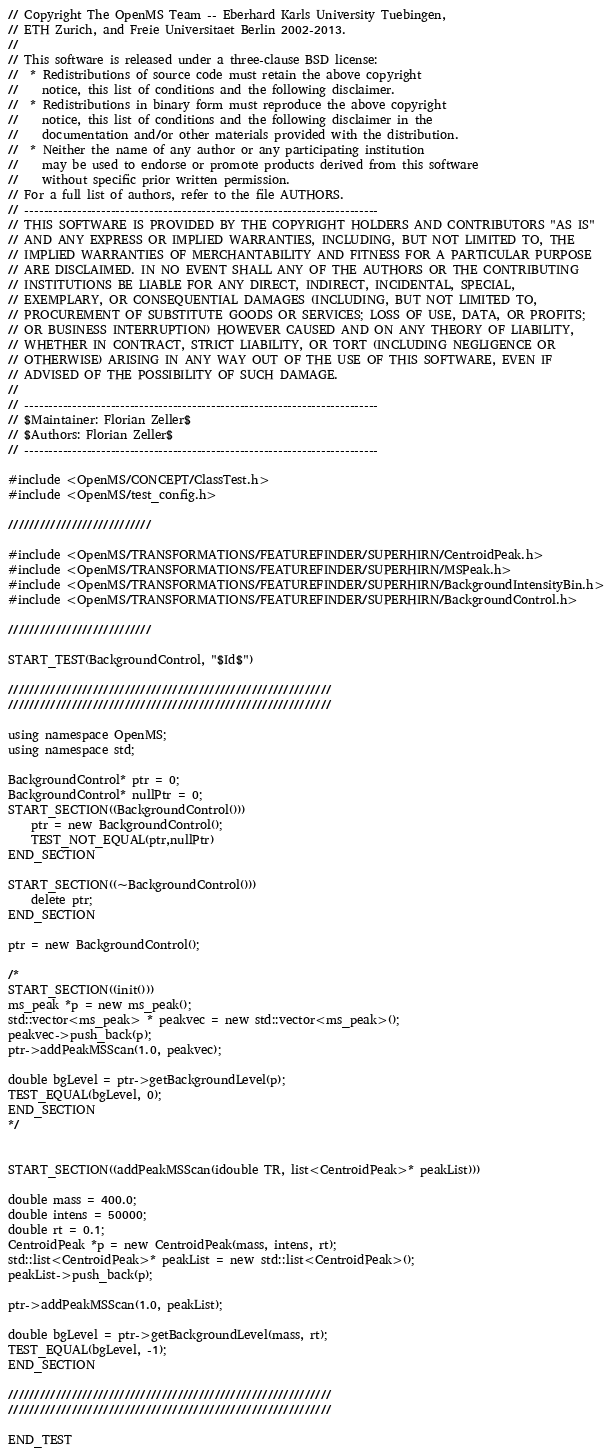Convert code to text. <code><loc_0><loc_0><loc_500><loc_500><_C++_>// Copyright The OpenMS Team -- Eberhard Karls University Tuebingen,
// ETH Zurich, and Freie Universitaet Berlin 2002-2013.
// 
// This software is released under a three-clause BSD license:
//  * Redistributions of source code must retain the above copyright
//    notice, this list of conditions and the following disclaimer.
//  * Redistributions in binary form must reproduce the above copyright
//    notice, this list of conditions and the following disclaimer in the
//    documentation and/or other materials provided with the distribution.
//  * Neither the name of any author or any participating institution 
//    may be used to endorse or promote products derived from this software 
//    without specific prior written permission.
// For a full list of authors, refer to the file AUTHORS. 
// --------------------------------------------------------------------------
// THIS SOFTWARE IS PROVIDED BY THE COPYRIGHT HOLDERS AND CONTRIBUTORS "AS IS"
// AND ANY EXPRESS OR IMPLIED WARRANTIES, INCLUDING, BUT NOT LIMITED TO, THE
// IMPLIED WARRANTIES OF MERCHANTABILITY AND FITNESS FOR A PARTICULAR PURPOSE
// ARE DISCLAIMED. IN NO EVENT SHALL ANY OF THE AUTHORS OR THE CONTRIBUTING 
// INSTITUTIONS BE LIABLE FOR ANY DIRECT, INDIRECT, INCIDENTAL, SPECIAL, 
// EXEMPLARY, OR CONSEQUENTIAL DAMAGES (INCLUDING, BUT NOT LIMITED TO, 
// PROCUREMENT OF SUBSTITUTE GOODS OR SERVICES; LOSS OF USE, DATA, OR PROFITS; 
// OR BUSINESS INTERRUPTION) HOWEVER CAUSED AND ON ANY THEORY OF LIABILITY, 
// WHETHER IN CONTRACT, STRICT LIABILITY, OR TORT (INCLUDING NEGLIGENCE OR 
// OTHERWISE) ARISING IN ANY WAY OUT OF THE USE OF THIS SOFTWARE, EVEN IF 
// ADVISED OF THE POSSIBILITY OF SUCH DAMAGE.
// 
// --------------------------------------------------------------------------
// $Maintainer: Florian Zeller$
// $Authors: Florian Zeller$
// --------------------------------------------------------------------------

#include <OpenMS/CONCEPT/ClassTest.h>
#include <OpenMS/test_config.h>

///////////////////////////

#include <OpenMS/TRANSFORMATIONS/FEATUREFINDER/SUPERHIRN/CentroidPeak.h>
#include <OpenMS/TRANSFORMATIONS/FEATUREFINDER/SUPERHIRN/MSPeak.h>
#include <OpenMS/TRANSFORMATIONS/FEATUREFINDER/SUPERHIRN/BackgroundIntensityBin.h>
#include <OpenMS/TRANSFORMATIONS/FEATUREFINDER/SUPERHIRN/BackgroundControl.h>

///////////////////////////

START_TEST(BackgroundControl, "$Id$")

/////////////////////////////////////////////////////////////
/////////////////////////////////////////////////////////////

using namespace OpenMS;
using namespace std;

BackgroundControl* ptr = 0;
BackgroundControl* nullPtr = 0;
START_SECTION((BackgroundControl()))
	ptr = new BackgroundControl();
	TEST_NOT_EQUAL(ptr,nullPtr)
END_SECTION

START_SECTION((~BackgroundControl()))
	delete ptr;
END_SECTION

ptr = new BackgroundControl();

/*
START_SECTION((init()))
ms_peak *p = new ms_peak();
std::vector<ms_peak> * peakvec = new std::vector<ms_peak>();
peakvec->push_back(p);
ptr->addPeakMSScan(1.0, peakvec);

double bgLevel = ptr->getBackgroundLevel(p);
TEST_EQUAL(bgLevel, 0);
END_SECTION
*/


START_SECTION((addPeakMSScan(idouble TR, list<CentroidPeak>* peakList)))

double mass = 400.0;
double intens = 50000;
double rt = 0.1;
CentroidPeak *p = new CentroidPeak(mass, intens, rt);
std::list<CentroidPeak>* peakList = new std::list<CentroidPeak>();
peakList->push_back(p);

ptr->addPeakMSScan(1.0, peakList);

double bgLevel = ptr->getBackgroundLevel(mass, rt);
TEST_EQUAL(bgLevel, -1);
END_SECTION

/////////////////////////////////////////////////////////////
/////////////////////////////////////////////////////////////

END_TEST
</code> 